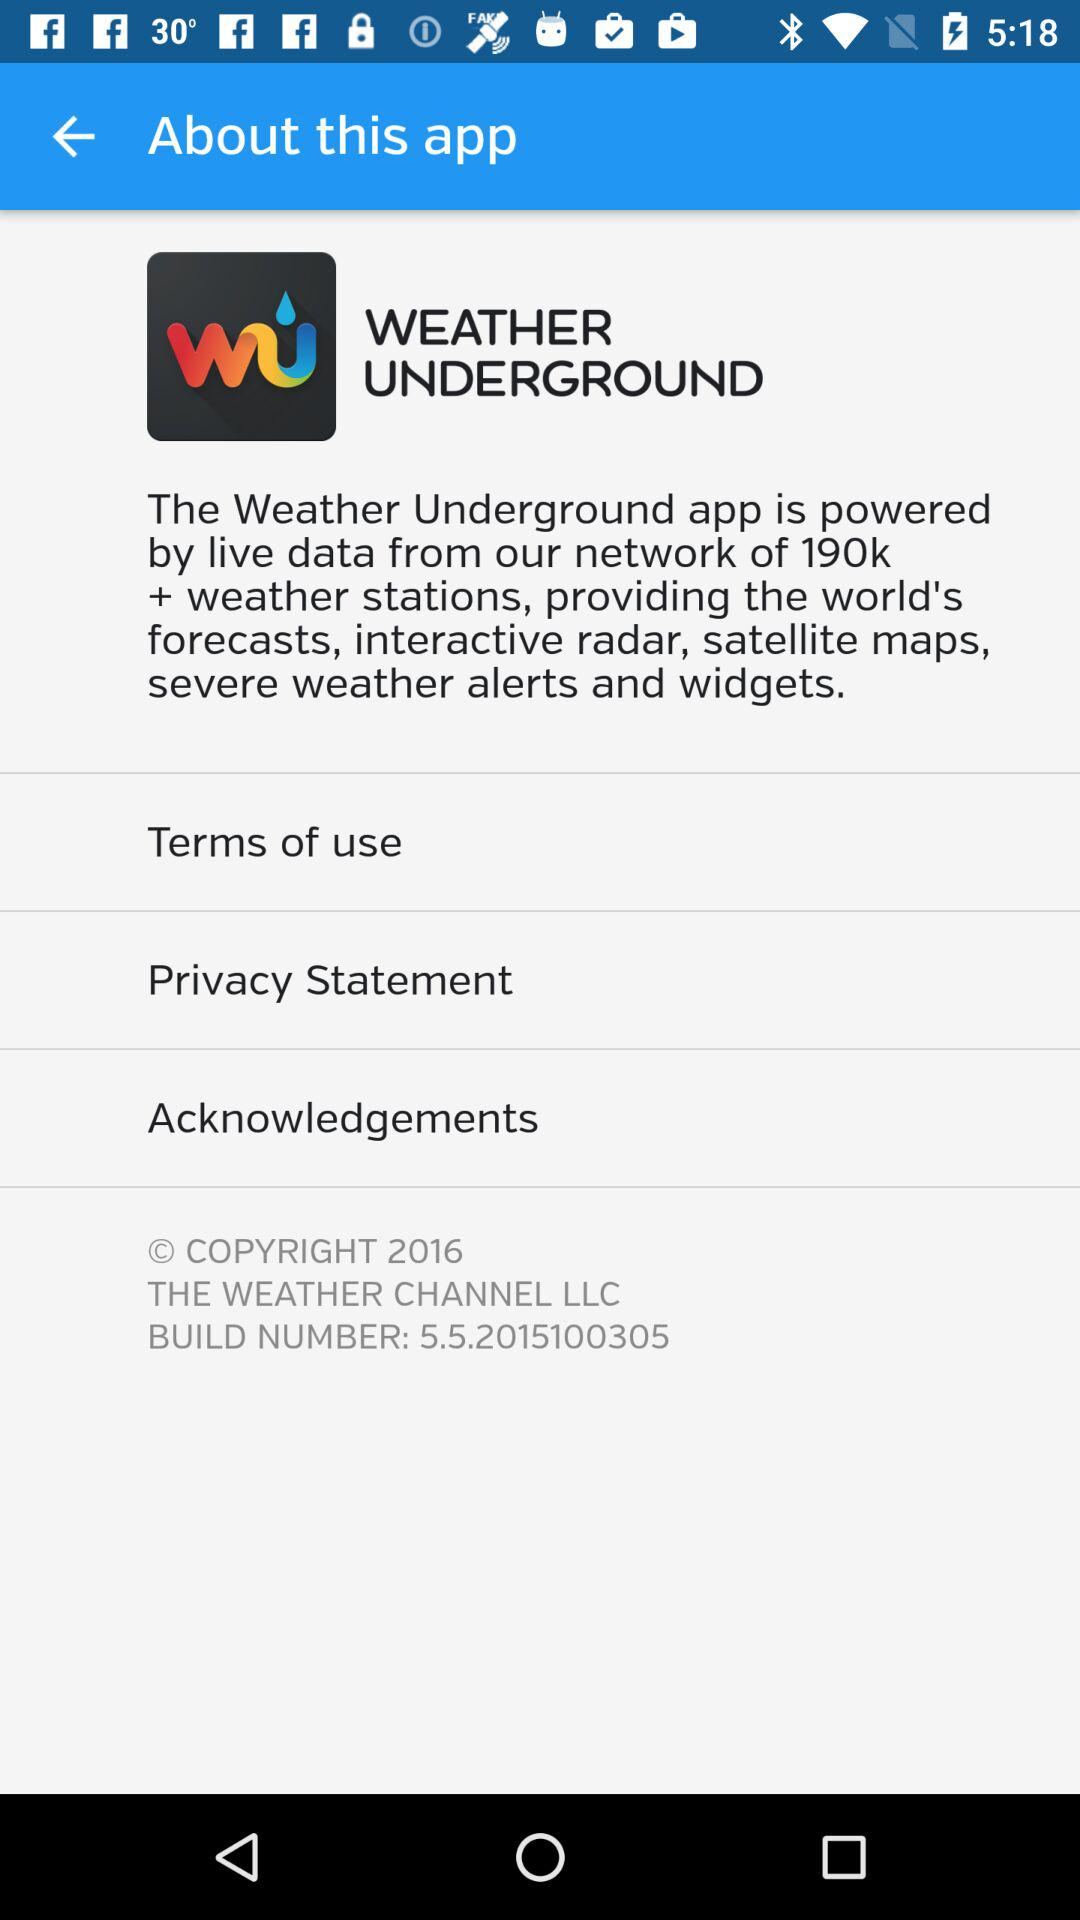How many weather stations are added to the weather underground app? The added weather stations are 190k+. 